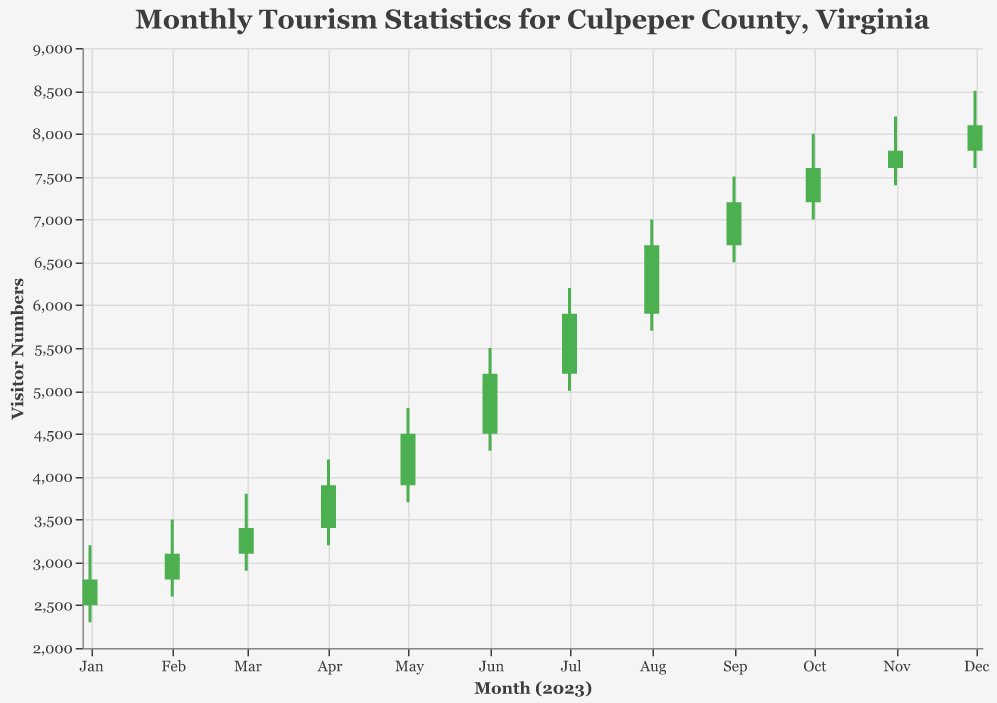What is the title of the figure? The title is displayed at the top of the chart. It reads "Monthly Tourism Statistics for Culpeper County, Virginia".
Answer: Monthly Tourism Statistics for Culpeper County, Virginia How many months are displayed in the chart? Each data point on the x-axis represents a month from January to December, so there are 12 months displayed.
Answer: 12 Which month had the highest visitor numbers (High value)? The highest visitor numbers can be seen by finding the month with the tallest vertical line, indicating the highest "High" value. This occurs in December with a high value of 8500.
Answer: December What was the Open and Close value for July? To find the Open and Close value for July, look for the bar corresponding to July. The Open is 5200 and the Close is 5900.
Answer: Open: 5200, Close: 5900 Which months showed an increase in visitor numbers by their Close values (Close > Open)? To see which months have an increase, identify the bars where the Close value (top of the bar) is higher than the Open value (bottom of the bar). These months are January, February, March, April, May, June, July, August, September, October, November, and December.
Answer: January to December What was the range of visitor numbers in March (difference between High and Low)? The range can be calculated by subtracting the Low value from the High value for March. The High in March is 3800 and the Low is 2900. So, the range is 3800 - 2900 = 900.
Answer: 900 During which month did visitor numbers have the smallest range (difference between High and Low)? To find the month with the smallest range, calculate the differences for each month and compare them. The smallest range is for November with High of 8200 and Low of 7400, so the range is 8200 - 7400 = 800.
Answer: November What is the overall trend observed in visitor numbers from January to December? By observing the gradual increase in both Open and Close values from January to December, the overall trend is an increase in visitor numbers over the year.
Answer: Increasing trend How many months did the Close value equal the High value? Check the bars to see if the Close value (top of the bar) reaches the High value. None of the months have their Close value equal to the High value.
Answer: None In which month did visitor numbers see the largest increase from Open to Close? To identify this, calculate the difference (Close - Open) for each month. The largest increase is in August, where the difference is 6700 - 5900 = 800.
Answer: August 